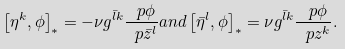<formula> <loc_0><loc_0><loc_500><loc_500>\left [ \eta ^ { k } , \phi \right ] _ { * } = - \nu g ^ { \bar { l } k } \frac { \ p \phi } { \ p \bar { z } ^ { l } } a n d \left [ \bar { \eta } ^ { l } , \phi \right ] _ { * } = \nu g ^ { \bar { l } k } \frac { \ p \phi } { \ p z ^ { k } } .</formula> 